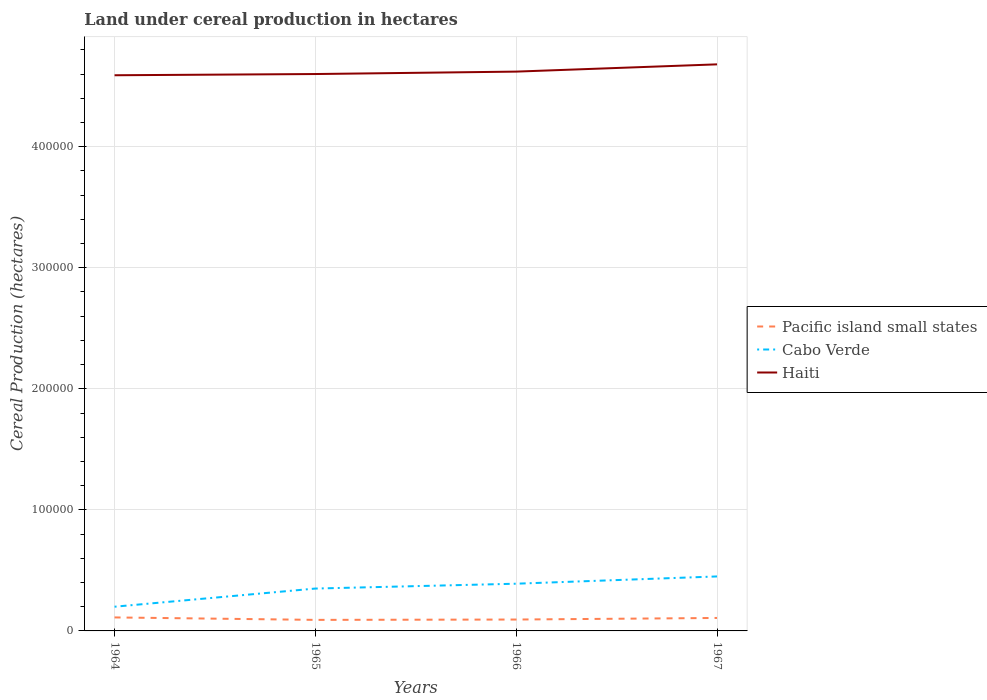Is the number of lines equal to the number of legend labels?
Provide a short and direct response. Yes. Across all years, what is the maximum land under cereal production in Cabo Verde?
Provide a short and direct response. 2.00e+04. In which year was the land under cereal production in Haiti maximum?
Your answer should be compact. 1964. What is the total land under cereal production in Cabo Verde in the graph?
Make the answer very short. -1.50e+04. What is the difference between the highest and the second highest land under cereal production in Haiti?
Your answer should be very brief. 9000. Is the land under cereal production in Pacific island small states strictly greater than the land under cereal production in Cabo Verde over the years?
Keep it short and to the point. Yes. How many years are there in the graph?
Give a very brief answer. 4. How are the legend labels stacked?
Give a very brief answer. Vertical. What is the title of the graph?
Your answer should be very brief. Land under cereal production in hectares. What is the label or title of the Y-axis?
Provide a short and direct response. Cereal Production (hectares). What is the Cereal Production (hectares) in Pacific island small states in 1964?
Offer a very short reply. 1.11e+04. What is the Cereal Production (hectares) of Haiti in 1964?
Your answer should be compact. 4.59e+05. What is the Cereal Production (hectares) of Pacific island small states in 1965?
Provide a succinct answer. 9122. What is the Cereal Production (hectares) in Cabo Verde in 1965?
Make the answer very short. 3.50e+04. What is the Cereal Production (hectares) of Haiti in 1965?
Provide a short and direct response. 4.60e+05. What is the Cereal Production (hectares) of Pacific island small states in 1966?
Give a very brief answer. 9409. What is the Cereal Production (hectares) of Cabo Verde in 1966?
Ensure brevity in your answer.  3.90e+04. What is the Cereal Production (hectares) in Haiti in 1966?
Your answer should be compact. 4.62e+05. What is the Cereal Production (hectares) in Pacific island small states in 1967?
Your answer should be very brief. 1.07e+04. What is the Cereal Production (hectares) in Cabo Verde in 1967?
Keep it short and to the point. 4.50e+04. What is the Cereal Production (hectares) of Haiti in 1967?
Offer a terse response. 4.68e+05. Across all years, what is the maximum Cereal Production (hectares) of Pacific island small states?
Give a very brief answer. 1.11e+04. Across all years, what is the maximum Cereal Production (hectares) of Cabo Verde?
Give a very brief answer. 4.50e+04. Across all years, what is the maximum Cereal Production (hectares) in Haiti?
Your answer should be very brief. 4.68e+05. Across all years, what is the minimum Cereal Production (hectares) of Pacific island small states?
Your response must be concise. 9122. Across all years, what is the minimum Cereal Production (hectares) in Cabo Verde?
Keep it short and to the point. 2.00e+04. Across all years, what is the minimum Cereal Production (hectares) in Haiti?
Keep it short and to the point. 4.59e+05. What is the total Cereal Production (hectares) of Pacific island small states in the graph?
Your response must be concise. 4.04e+04. What is the total Cereal Production (hectares) in Cabo Verde in the graph?
Keep it short and to the point. 1.39e+05. What is the total Cereal Production (hectares) in Haiti in the graph?
Offer a terse response. 1.85e+06. What is the difference between the Cereal Production (hectares) of Pacific island small states in 1964 and that in 1965?
Give a very brief answer. 2027. What is the difference between the Cereal Production (hectares) in Cabo Verde in 1964 and that in 1965?
Offer a very short reply. -1.50e+04. What is the difference between the Cereal Production (hectares) of Haiti in 1964 and that in 1965?
Make the answer very short. -1000. What is the difference between the Cereal Production (hectares) of Pacific island small states in 1964 and that in 1966?
Ensure brevity in your answer.  1740. What is the difference between the Cereal Production (hectares) in Cabo Verde in 1964 and that in 1966?
Offer a very short reply. -1.90e+04. What is the difference between the Cereal Production (hectares) of Haiti in 1964 and that in 1966?
Keep it short and to the point. -3000. What is the difference between the Cereal Production (hectares) in Pacific island small states in 1964 and that in 1967?
Your answer should be very brief. 440. What is the difference between the Cereal Production (hectares) of Cabo Verde in 1964 and that in 1967?
Provide a succinct answer. -2.50e+04. What is the difference between the Cereal Production (hectares) in Haiti in 1964 and that in 1967?
Provide a short and direct response. -9000. What is the difference between the Cereal Production (hectares) in Pacific island small states in 1965 and that in 1966?
Provide a short and direct response. -287. What is the difference between the Cereal Production (hectares) in Cabo Verde in 1965 and that in 1966?
Provide a succinct answer. -4000. What is the difference between the Cereal Production (hectares) in Haiti in 1965 and that in 1966?
Make the answer very short. -2000. What is the difference between the Cereal Production (hectares) in Pacific island small states in 1965 and that in 1967?
Make the answer very short. -1587. What is the difference between the Cereal Production (hectares) in Haiti in 1965 and that in 1967?
Offer a very short reply. -8000. What is the difference between the Cereal Production (hectares) in Pacific island small states in 1966 and that in 1967?
Provide a short and direct response. -1300. What is the difference between the Cereal Production (hectares) in Cabo Verde in 1966 and that in 1967?
Offer a terse response. -6000. What is the difference between the Cereal Production (hectares) in Haiti in 1966 and that in 1967?
Your response must be concise. -6000. What is the difference between the Cereal Production (hectares) of Pacific island small states in 1964 and the Cereal Production (hectares) of Cabo Verde in 1965?
Ensure brevity in your answer.  -2.39e+04. What is the difference between the Cereal Production (hectares) in Pacific island small states in 1964 and the Cereal Production (hectares) in Haiti in 1965?
Offer a very short reply. -4.49e+05. What is the difference between the Cereal Production (hectares) in Cabo Verde in 1964 and the Cereal Production (hectares) in Haiti in 1965?
Your response must be concise. -4.40e+05. What is the difference between the Cereal Production (hectares) of Pacific island small states in 1964 and the Cereal Production (hectares) of Cabo Verde in 1966?
Your answer should be compact. -2.79e+04. What is the difference between the Cereal Production (hectares) in Pacific island small states in 1964 and the Cereal Production (hectares) in Haiti in 1966?
Make the answer very short. -4.51e+05. What is the difference between the Cereal Production (hectares) of Cabo Verde in 1964 and the Cereal Production (hectares) of Haiti in 1966?
Make the answer very short. -4.42e+05. What is the difference between the Cereal Production (hectares) in Pacific island small states in 1964 and the Cereal Production (hectares) in Cabo Verde in 1967?
Provide a short and direct response. -3.39e+04. What is the difference between the Cereal Production (hectares) of Pacific island small states in 1964 and the Cereal Production (hectares) of Haiti in 1967?
Provide a short and direct response. -4.57e+05. What is the difference between the Cereal Production (hectares) in Cabo Verde in 1964 and the Cereal Production (hectares) in Haiti in 1967?
Give a very brief answer. -4.48e+05. What is the difference between the Cereal Production (hectares) in Pacific island small states in 1965 and the Cereal Production (hectares) in Cabo Verde in 1966?
Your response must be concise. -2.99e+04. What is the difference between the Cereal Production (hectares) of Pacific island small states in 1965 and the Cereal Production (hectares) of Haiti in 1966?
Provide a short and direct response. -4.53e+05. What is the difference between the Cereal Production (hectares) of Cabo Verde in 1965 and the Cereal Production (hectares) of Haiti in 1966?
Ensure brevity in your answer.  -4.27e+05. What is the difference between the Cereal Production (hectares) in Pacific island small states in 1965 and the Cereal Production (hectares) in Cabo Verde in 1967?
Provide a short and direct response. -3.59e+04. What is the difference between the Cereal Production (hectares) in Pacific island small states in 1965 and the Cereal Production (hectares) in Haiti in 1967?
Your response must be concise. -4.59e+05. What is the difference between the Cereal Production (hectares) of Cabo Verde in 1965 and the Cereal Production (hectares) of Haiti in 1967?
Your answer should be compact. -4.33e+05. What is the difference between the Cereal Production (hectares) in Pacific island small states in 1966 and the Cereal Production (hectares) in Cabo Verde in 1967?
Your response must be concise. -3.56e+04. What is the difference between the Cereal Production (hectares) of Pacific island small states in 1966 and the Cereal Production (hectares) of Haiti in 1967?
Your response must be concise. -4.59e+05. What is the difference between the Cereal Production (hectares) in Cabo Verde in 1966 and the Cereal Production (hectares) in Haiti in 1967?
Your answer should be compact. -4.29e+05. What is the average Cereal Production (hectares) in Pacific island small states per year?
Offer a very short reply. 1.01e+04. What is the average Cereal Production (hectares) in Cabo Verde per year?
Offer a terse response. 3.48e+04. What is the average Cereal Production (hectares) of Haiti per year?
Make the answer very short. 4.62e+05. In the year 1964, what is the difference between the Cereal Production (hectares) in Pacific island small states and Cereal Production (hectares) in Cabo Verde?
Make the answer very short. -8851. In the year 1964, what is the difference between the Cereal Production (hectares) in Pacific island small states and Cereal Production (hectares) in Haiti?
Provide a short and direct response. -4.48e+05. In the year 1964, what is the difference between the Cereal Production (hectares) of Cabo Verde and Cereal Production (hectares) of Haiti?
Offer a very short reply. -4.39e+05. In the year 1965, what is the difference between the Cereal Production (hectares) in Pacific island small states and Cereal Production (hectares) in Cabo Verde?
Give a very brief answer. -2.59e+04. In the year 1965, what is the difference between the Cereal Production (hectares) in Pacific island small states and Cereal Production (hectares) in Haiti?
Your answer should be compact. -4.51e+05. In the year 1965, what is the difference between the Cereal Production (hectares) in Cabo Verde and Cereal Production (hectares) in Haiti?
Give a very brief answer. -4.25e+05. In the year 1966, what is the difference between the Cereal Production (hectares) of Pacific island small states and Cereal Production (hectares) of Cabo Verde?
Make the answer very short. -2.96e+04. In the year 1966, what is the difference between the Cereal Production (hectares) in Pacific island small states and Cereal Production (hectares) in Haiti?
Give a very brief answer. -4.53e+05. In the year 1966, what is the difference between the Cereal Production (hectares) of Cabo Verde and Cereal Production (hectares) of Haiti?
Your answer should be compact. -4.23e+05. In the year 1967, what is the difference between the Cereal Production (hectares) in Pacific island small states and Cereal Production (hectares) in Cabo Verde?
Give a very brief answer. -3.43e+04. In the year 1967, what is the difference between the Cereal Production (hectares) in Pacific island small states and Cereal Production (hectares) in Haiti?
Ensure brevity in your answer.  -4.57e+05. In the year 1967, what is the difference between the Cereal Production (hectares) in Cabo Verde and Cereal Production (hectares) in Haiti?
Provide a short and direct response. -4.23e+05. What is the ratio of the Cereal Production (hectares) of Pacific island small states in 1964 to that in 1965?
Your answer should be very brief. 1.22. What is the ratio of the Cereal Production (hectares) in Cabo Verde in 1964 to that in 1965?
Your answer should be compact. 0.57. What is the ratio of the Cereal Production (hectares) in Haiti in 1964 to that in 1965?
Provide a short and direct response. 1. What is the ratio of the Cereal Production (hectares) in Pacific island small states in 1964 to that in 1966?
Ensure brevity in your answer.  1.18. What is the ratio of the Cereal Production (hectares) of Cabo Verde in 1964 to that in 1966?
Give a very brief answer. 0.51. What is the ratio of the Cereal Production (hectares) of Pacific island small states in 1964 to that in 1967?
Provide a short and direct response. 1.04. What is the ratio of the Cereal Production (hectares) of Cabo Verde in 1964 to that in 1967?
Your answer should be very brief. 0.44. What is the ratio of the Cereal Production (hectares) in Haiti in 1964 to that in 1967?
Provide a succinct answer. 0.98. What is the ratio of the Cereal Production (hectares) in Pacific island small states in 1965 to that in 1966?
Offer a very short reply. 0.97. What is the ratio of the Cereal Production (hectares) in Cabo Verde in 1965 to that in 1966?
Your answer should be very brief. 0.9. What is the ratio of the Cereal Production (hectares) of Pacific island small states in 1965 to that in 1967?
Offer a terse response. 0.85. What is the ratio of the Cereal Production (hectares) in Cabo Verde in 1965 to that in 1967?
Make the answer very short. 0.78. What is the ratio of the Cereal Production (hectares) of Haiti in 1965 to that in 1967?
Make the answer very short. 0.98. What is the ratio of the Cereal Production (hectares) of Pacific island small states in 1966 to that in 1967?
Give a very brief answer. 0.88. What is the ratio of the Cereal Production (hectares) in Cabo Verde in 1966 to that in 1967?
Your answer should be compact. 0.87. What is the ratio of the Cereal Production (hectares) of Haiti in 1966 to that in 1967?
Your answer should be compact. 0.99. What is the difference between the highest and the second highest Cereal Production (hectares) in Pacific island small states?
Make the answer very short. 440. What is the difference between the highest and the second highest Cereal Production (hectares) in Cabo Verde?
Provide a short and direct response. 6000. What is the difference between the highest and the second highest Cereal Production (hectares) of Haiti?
Keep it short and to the point. 6000. What is the difference between the highest and the lowest Cereal Production (hectares) of Pacific island small states?
Give a very brief answer. 2027. What is the difference between the highest and the lowest Cereal Production (hectares) of Cabo Verde?
Offer a terse response. 2.50e+04. What is the difference between the highest and the lowest Cereal Production (hectares) of Haiti?
Give a very brief answer. 9000. 